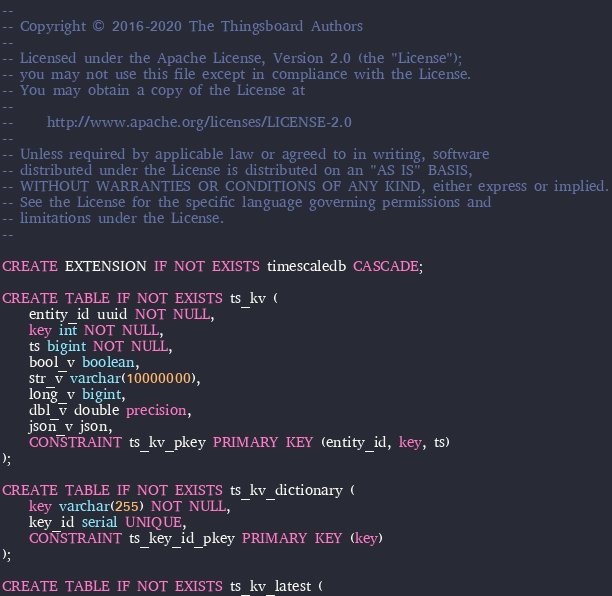Convert code to text. <code><loc_0><loc_0><loc_500><loc_500><_SQL_>--
-- Copyright © 2016-2020 The Thingsboard Authors
--
-- Licensed under the Apache License, Version 2.0 (the "License");
-- you may not use this file except in compliance with the License.
-- You may obtain a copy of the License at
--
--     http://www.apache.org/licenses/LICENSE-2.0
--
-- Unless required by applicable law or agreed to in writing, software
-- distributed under the License is distributed on an "AS IS" BASIS,
-- WITHOUT WARRANTIES OR CONDITIONS OF ANY KIND, either express or implied.
-- See the License for the specific language governing permissions and
-- limitations under the License.
--

CREATE EXTENSION IF NOT EXISTS timescaledb CASCADE;

CREATE TABLE IF NOT EXISTS ts_kv (
    entity_id uuid NOT NULL,
    key int NOT NULL,
    ts bigint NOT NULL,
    bool_v boolean,
    str_v varchar(10000000),
    long_v bigint,
    dbl_v double precision,
    json_v json,
    CONSTRAINT ts_kv_pkey PRIMARY KEY (entity_id, key, ts)
);

CREATE TABLE IF NOT EXISTS ts_kv_dictionary (
    key varchar(255) NOT NULL,
    key_id serial UNIQUE,
    CONSTRAINT ts_key_id_pkey PRIMARY KEY (key)
);

CREATE TABLE IF NOT EXISTS ts_kv_latest (</code> 